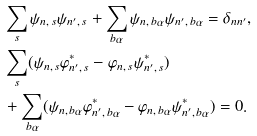Convert formula to latex. <formula><loc_0><loc_0><loc_500><loc_500>& \sum _ { s } \psi _ { n , \, s } \psi _ { { n ^ { \prime } } , \, s } + \sum _ { b \alpha } \psi _ { n , \, b \alpha } \psi _ { { n ^ { \prime } } , \, b \alpha } = \delta _ { n n ^ { \prime } } , \\ & \sum _ { s } ( \psi _ { n , \, s } \varphi ^ { * } _ { { n ^ { \prime } } , \, s } - \varphi _ { n , \, s } \psi ^ { * } _ { { n ^ { \prime } } , \, s } ) \\ & + \sum _ { b \alpha } ( \psi _ { n , \, b \alpha } \varphi ^ { * } _ { { n ^ { \prime } } , \, b \alpha } - \varphi _ { n , \, b \alpha } \psi ^ { * } _ { { n ^ { \prime } } , \, b \alpha } ) = 0 .</formula> 